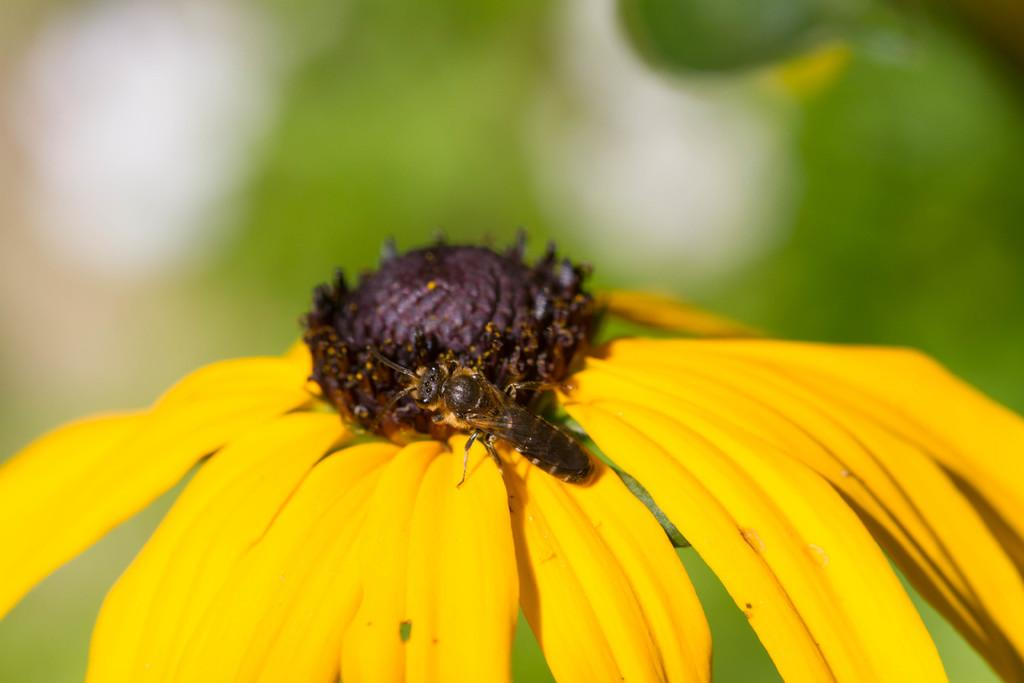What type of plant is in the picture? There is a sunflower in the picture. What color is the sunflower? The sunflower is yellow in color. Is there any other living organism present on the sunflower? Yes, there is a honey bee on the sunflower. What is the weight of the business on top of the sunflower? There is no business or weight present on the sunflower; it is a honey bee that is on the sunflower. 